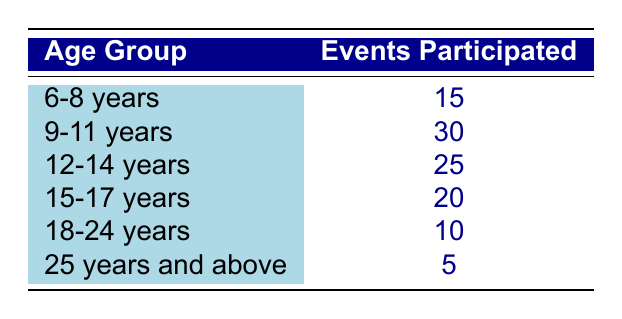What is the age group with the highest number of events participated? From the table, we see that the age group "9-11 years" has the highest number of events participated, totaling 30.
Answer: 9-11 years How many events participated by the age group "25 years and above"? The table shows that the age group "25 years and above" participated in 5 events.
Answer: 5 What is the total number of events participated by age groups "6-8 years" and "9-11 years"? We add the events of "6-8 years" (15) and "9-11 years" (30), which gives us 15 + 30 = 45 events in total.
Answer: 45 Is the total number of events participated by age group "18-24 years" greater than that of "15-17 years"? From the table, "18-24 years" participated in 10 events, and "15-17 years" participated in 20 events, so 10 is not greater than 20.
Answer: No What is the average number of events participated across all age groups? To find the average, sum all events: 15 + 30 + 25 + 20 + 10 + 5 = 105. There are 6 age groups, so the average is 105 / 6 = 17.5.
Answer: 17.5 How many more events were participated by the age group "12-14 years" compared to "25 years and above"? The age group "12-14 years" had 25 events and "25 years and above" had 5 events. Thus, 25 - 5 = 20 more events participated by "12-14 years."
Answer: 20 What is the total number of events participated by age groups "18-24 years" and "25 years and above"? The age group "18-24 years" participated in 10 events, and "25 years and above" participated in 5. Adding those gives us 10 + 5 = 15 events.
Answer: 15 Which age group has the second highest participation in events? The second highest participation is "12-14 years" with 25 events, following "9-11 years" with 30 events.
Answer: 12-14 years 